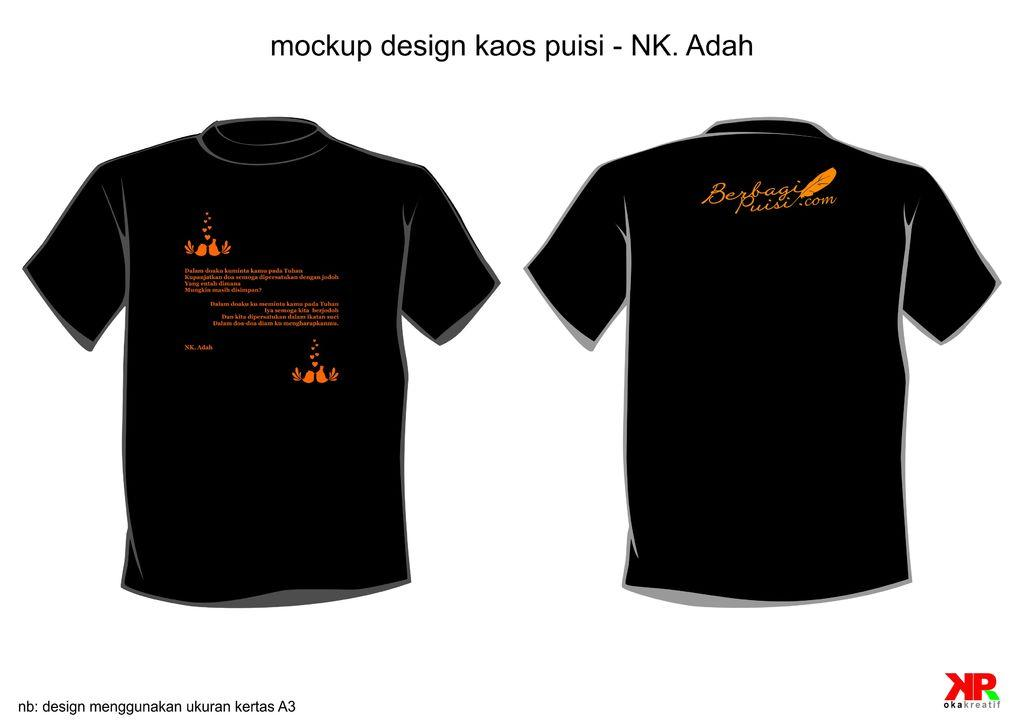What type of clothing is featured in the image? There are two black t-shirts in the image. What is written on the t-shirts? There is writing in orange on the t-shirts. How does the rice feel in the image? There is no rice present in the image, so it cannot be felt or described. 